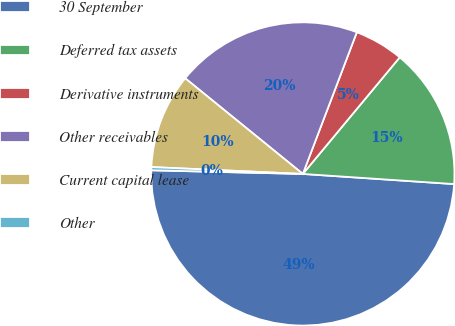Convert chart to OTSL. <chart><loc_0><loc_0><loc_500><loc_500><pie_chart><fcel>30 September<fcel>Deferred tax assets<fcel>Derivative instruments<fcel>Other receivables<fcel>Current capital lease<fcel>Other<nl><fcel>49.31%<fcel>15.03%<fcel>5.24%<fcel>19.93%<fcel>10.14%<fcel>0.34%<nl></chart> 